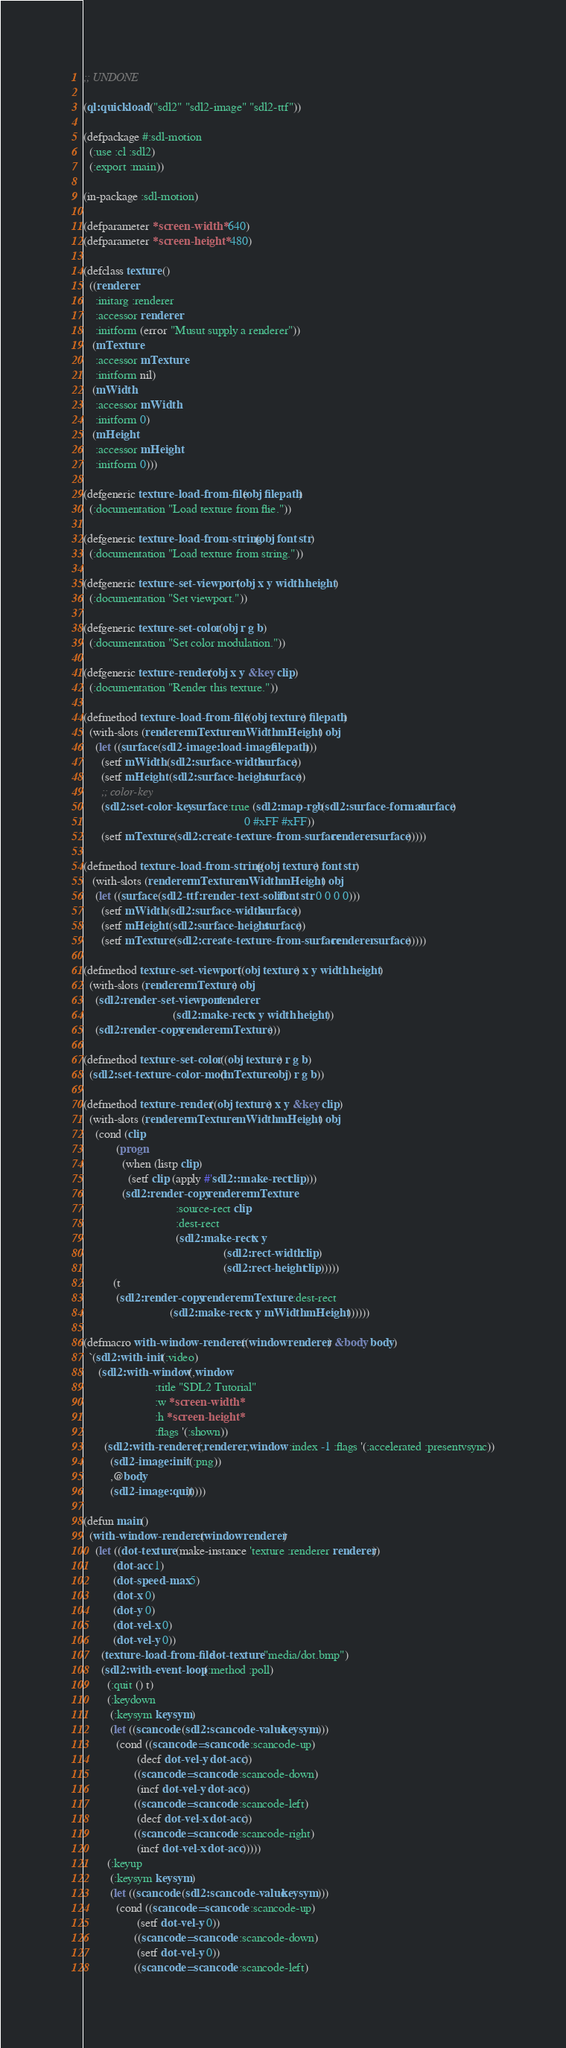<code> <loc_0><loc_0><loc_500><loc_500><_Lisp_>;; UNDONE

(ql:quickload '("sdl2" "sdl2-image" "sdl2-ttf"))

(defpackage #:sdl-motion
  (:use :cl :sdl2)
  (:export :main))

(in-package :sdl-motion)

(defparameter *screen-width* 640)
(defparameter *screen-height* 480)

(defclass texture ()
  ((renderer
    :initarg :renderer
    :accessor renderer
    :initform (error "Musut supply a renderer"))
   (mTexture
    :accessor mTexture
    :initform nil)
   (mWidth
    :accessor mWidth
    :initform 0)
   (mHeight
    :accessor mHeight
    :initform 0)))

(defgeneric texture-load-from-file (obj filepath)
  (:documentation "Load texture from flie."))

(defgeneric texture-load-from-string (obj font str)
  (:documentation "Load texture from string."))

(defgeneric texture-set-viewport (obj x y width height)
  (:documentation "Set viewport."))

(defgeneric texture-set-color (obj r g b)
  (:documentation "Set color modulation."))

(defgeneric texture-render (obj x y &key clip)
  (:documentation "Render this texture."))

(defmethod texture-load-from-file ((obj texture) filepath)
  (with-slots (renderer mTexture mWidth mHeight) obj
    (let ((surface (sdl2-image:load-image filepath)))
      (setf mWidth (sdl2:surface-width surface))
      (setf mHeight (sdl2:surface-height surface))
      ;; color-key 
      (sdl2:set-color-key surface :true (sdl2:map-rgb (sdl2:surface-format surface)
                                                      0 #xFF #xFF))
      (setf mTexture (sdl2:create-texture-from-surface renderer surface)))))

(defmethod texture-load-from-string ((obj texture) font str)
   (with-slots (renderer mTexture mWidth mHeight) obj
    (let ((surface (sdl2-ttf:render-text-solid font str 0 0 0 0)))
      (setf mWidth (sdl2:surface-width surface))
      (setf mHeight (sdl2:surface-height surface))
      (setf mTexture (sdl2:create-texture-from-surface renderer surface)))))

(defmethod texture-set-viewport ((obj texture) x y width height)
  (with-slots (renderer mTexture) obj
    (sdl2:render-set-viewport renderer
                              (sdl2:make-rect x y width height))
    (sdl2:render-copy renderer mTexture)))

(defmethod texture-set-color ((obj texture) r g b)
  (sdl2:set-texture-color-mod (mTexture obj) r g b))

(defmethod texture-render ((obj texture) x y &key clip)
  (with-slots (renderer mTexture mWidth mHeight) obj
    (cond (clip
           (progn
             (when (listp clip)
               (setf clip (apply #'sdl2::make-rect clip)))
             (sdl2:render-copy renderer mTexture
                               :source-rect clip
                               :dest-rect
                               (sdl2:make-rect x y
                                               (sdl2:rect-width clip)
                                               (sdl2:rect-height clip)))))
          (t
           (sdl2:render-copy renderer mTexture :dest-rect
                             (sdl2:make-rect x y mWidth mHeight))))))

(defmacro with-window-renderer ((window renderer) &body body)
  `(sdl2:with-init (:video)
     (sdl2:with-window (,window
                        :title "SDL2 Tutorial"
                        :w *screen-width*
                        :h *screen-height*
                        :flags '(:shown))
       (sdl2:with-renderer (,renderer ,window :index -1 :flags '(:accelerated :presentvsync))
         (sdl2-image:init '(:png))
         ,@body
         (sdl2-image:quit)))))

(defun main()
  (with-window-renderer (window renderer)
    (let ((dot-texture (make-instance 'texture :renderer renderer))
          (dot-acc 1)
          (dot-speed-max 5)
          (dot-x 0)
          (dot-y 0)
          (dot-vel-x 0)
          (dot-vel-y 0))
      (texture-load-from-file dot-texture "media/dot.bmp")
      (sdl2:with-event-loop (:method :poll)
        (:quit () t)
        (:keydown
         (:keysym keysym)
         (let ((scancode (sdl2:scancode-value keysym)))
           (cond ((scancode= scancode :scancode-up)
                  (decf dot-vel-y dot-acc))
                 ((scancode= scancode :scancode-down)
                  (incf dot-vel-y dot-acc))
                 ((scancode= scancode :scancode-left)
                  (decf dot-vel-x dot-acc))
                 ((scancode= scancode :scancode-right)
                  (incf dot-vel-x dot-acc)))))
        (:keyup
         (:keysym keysym)
         (let ((scancode (sdl2:scancode-value keysym)))
           (cond ((scancode= scancode :scancode-up)
                  (setf dot-vel-y 0))
                 ((scancode= scancode :scancode-down)
                  (setf dot-vel-y 0))
                 ((scancode= scancode :scancode-left)</code> 